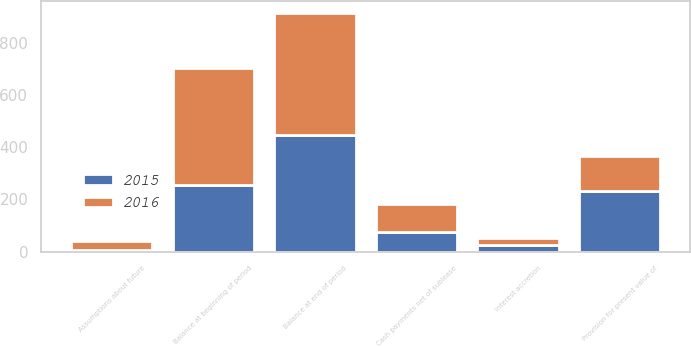Convert chart. <chart><loc_0><loc_0><loc_500><loc_500><stacked_bar_chart><ecel><fcel>Balance at beginning of period<fcel>Provision for present value of<fcel>Assumptions about future<fcel>Interest accretion<fcel>Cash payments net of sublease<fcel>Balance at end of period<nl><fcel>2016<fcel>446<fcel>134<fcel>34<fcel>27<fcel>107<fcel>466<nl><fcel>2015<fcel>257<fcel>231<fcel>6<fcel>27<fcel>76<fcel>446<nl></chart> 